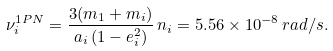<formula> <loc_0><loc_0><loc_500><loc_500>\nu _ { i } ^ { 1 P N } = \frac { 3 ( m _ { 1 } + m _ { i } ) } { a _ { i } \, ( 1 - e _ { i } ^ { 2 } ) } \, n _ { i } = 5 . 5 6 \times 1 0 ^ { - 8 } \, r a d / s .</formula> 